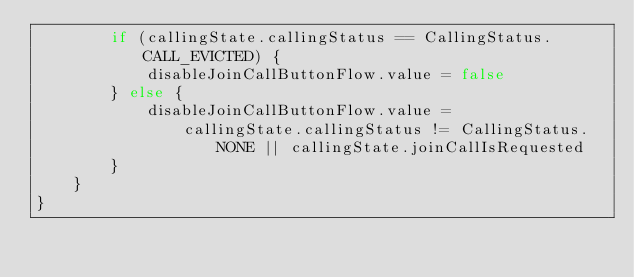<code> <loc_0><loc_0><loc_500><loc_500><_Kotlin_>        if (callingState.callingStatus == CallingStatus.CALL_EVICTED) {
            disableJoinCallButtonFlow.value = false
        } else {
            disableJoinCallButtonFlow.value =
                callingState.callingStatus != CallingStatus.NONE || callingState.joinCallIsRequested
        }
    }
}
</code> 